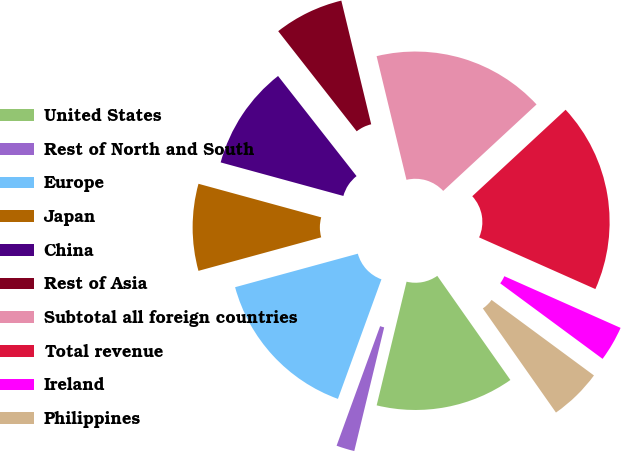<chart> <loc_0><loc_0><loc_500><loc_500><pie_chart><fcel>United States<fcel>Rest of North and South<fcel>Europe<fcel>Japan<fcel>China<fcel>Rest of Asia<fcel>Subtotal all foreign countries<fcel>Total revenue<fcel>Ireland<fcel>Philippines<nl><fcel>13.52%<fcel>1.78%<fcel>15.2%<fcel>8.49%<fcel>10.17%<fcel>6.81%<fcel>16.88%<fcel>18.55%<fcel>3.46%<fcel>5.14%<nl></chart> 